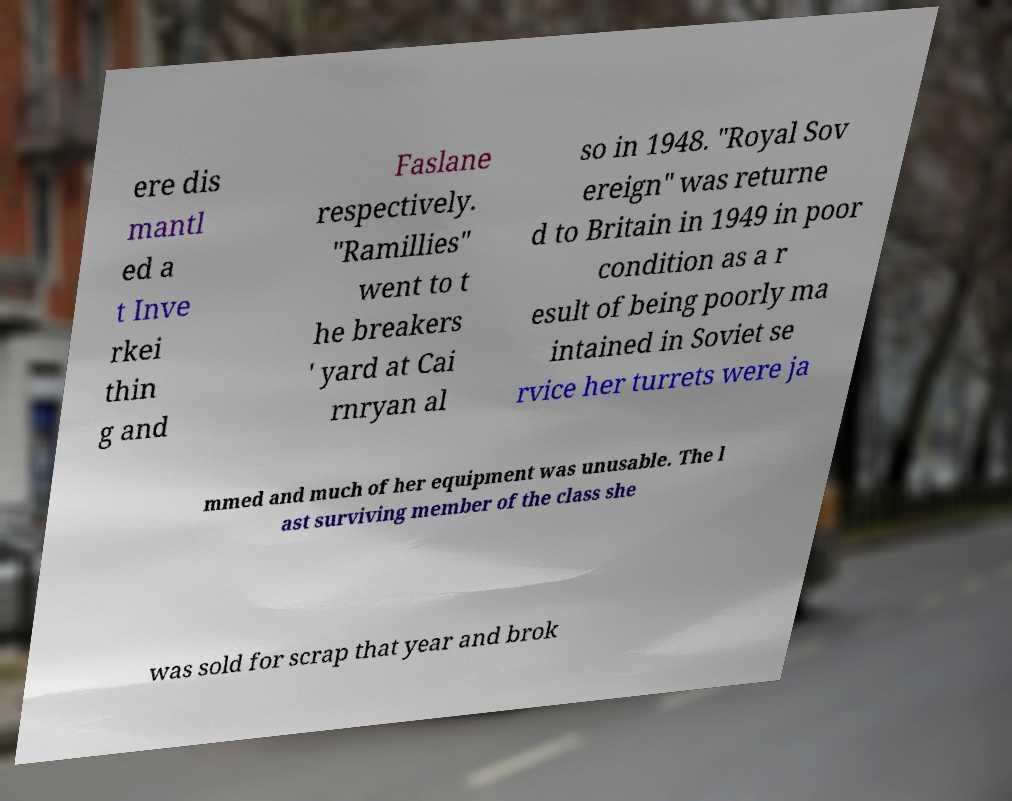I need the written content from this picture converted into text. Can you do that? ere dis mantl ed a t Inve rkei thin g and Faslane respectively. "Ramillies" went to t he breakers ' yard at Cai rnryan al so in 1948. "Royal Sov ereign" was returne d to Britain in 1949 in poor condition as a r esult of being poorly ma intained in Soviet se rvice her turrets were ja mmed and much of her equipment was unusable. The l ast surviving member of the class she was sold for scrap that year and brok 